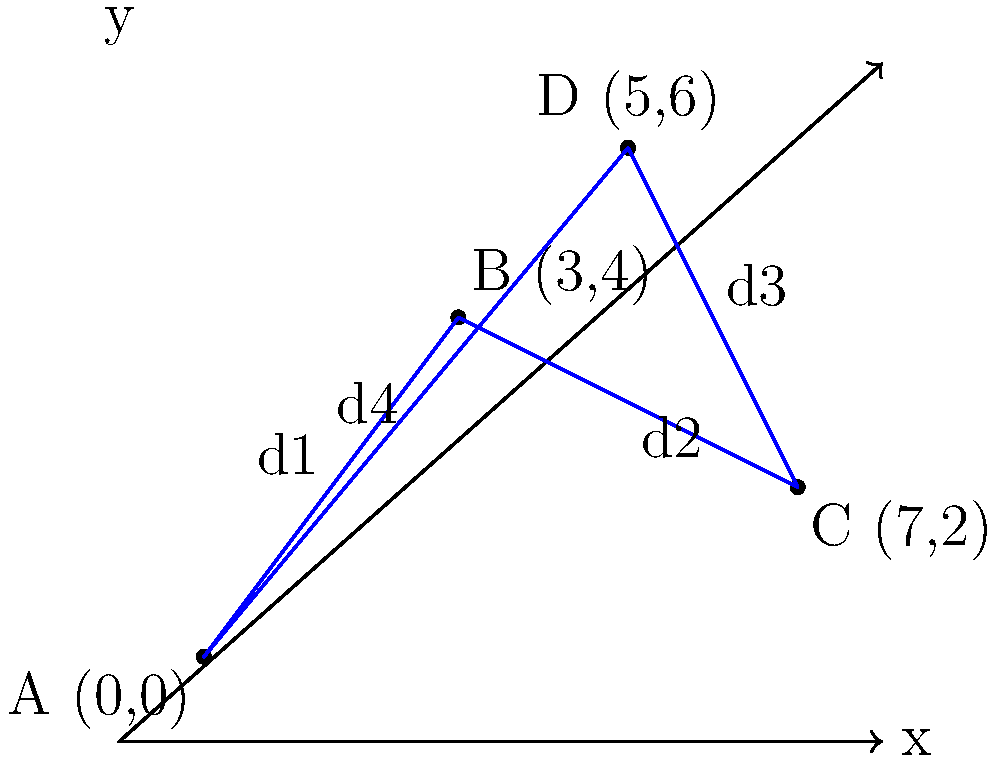As an environmental scientist, you are tasked with optimizing the transportation route between four eco-friendly manufacturing sites (A, B, C, and D) to minimize fuel consumption and emissions. The sites are located on a coordinate plane as shown in the diagram. Calculate the total distance of the route A → B → C → D → A, given that the distance between two points $(x_1, y_1)$ and $(x_2, y_2)$ is calculated using the formula:

$$ d = \sqrt{(x_2 - x_1)^2 + (y_2 - y_1)^2} $$

Round your answer to two decimal places. To solve this problem, we need to calculate the distances between each pair of consecutive points and sum them up. Let's break it down step by step:

1. Distance from A(0,0) to B(3,4):
   $d_1 = \sqrt{(3-0)^2 + (4-0)^2} = \sqrt{9 + 16} = \sqrt{25} = 5$

2. Distance from B(3,4) to C(7,2):
   $d_2 = \sqrt{(7-3)^2 + (2-4)^2} = \sqrt{16 + 4} = \sqrt{20} = 2\sqrt{5} \approx 4.47$

3. Distance from C(7,2) to D(5,6):
   $d_3 = \sqrt{(5-7)^2 + (6-2)^2} = \sqrt{4 + 16} = \sqrt{20} = 2\sqrt{5} \approx 4.47$

4. Distance from D(5,6) to A(0,0):
   $d_4 = \sqrt{(0-5)^2 + (0-6)^2} = \sqrt{25 + 36} = \sqrt{61} \approx 7.81$

5. Total distance:
   $d_{total} = d_1 + d_2 + d_3 + d_4$
   $d_{total} = 5 + 4.47 + 4.47 + 7.81 = 21.75$

Rounding to two decimal places, we get 21.75.
Answer: 21.75 units 